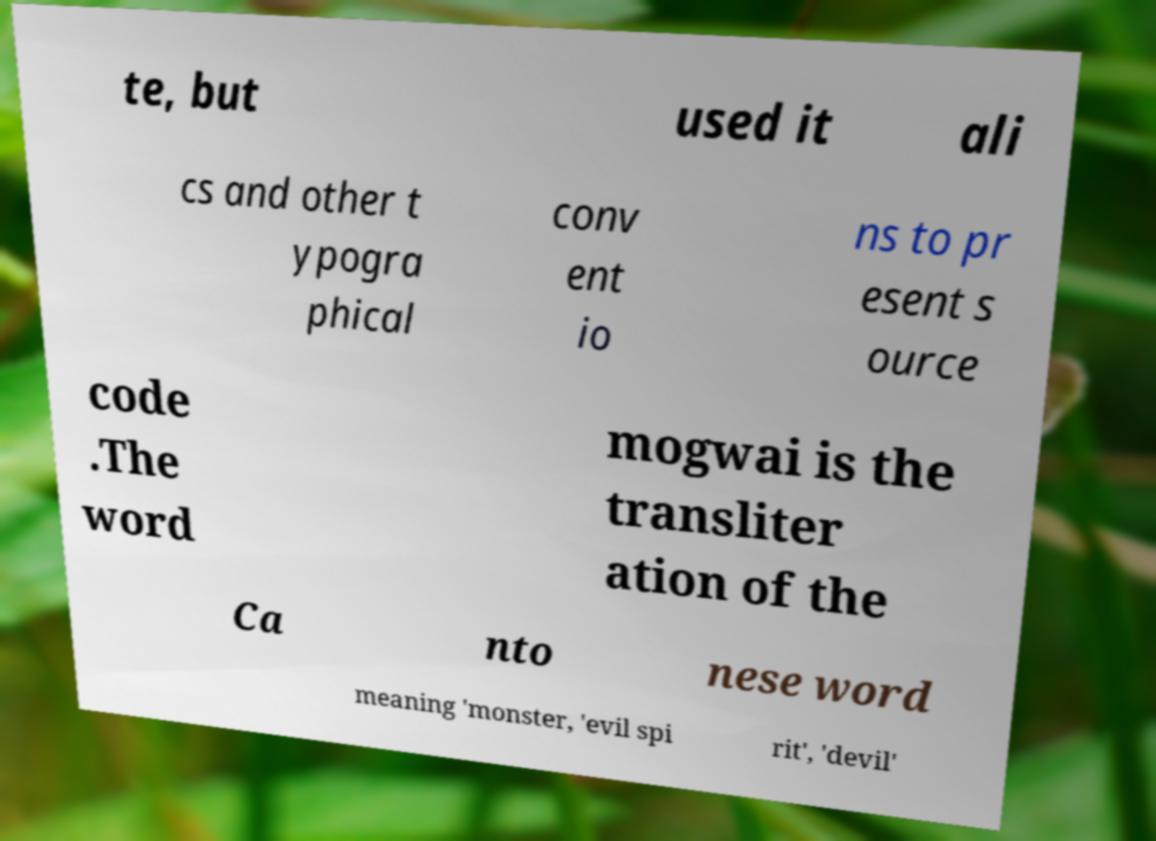Could you extract and type out the text from this image? te, but used it ali cs and other t ypogra phical conv ent io ns to pr esent s ource code .The word mogwai is the transliter ation of the Ca nto nese word meaning 'monster, 'evil spi rit', 'devil' 